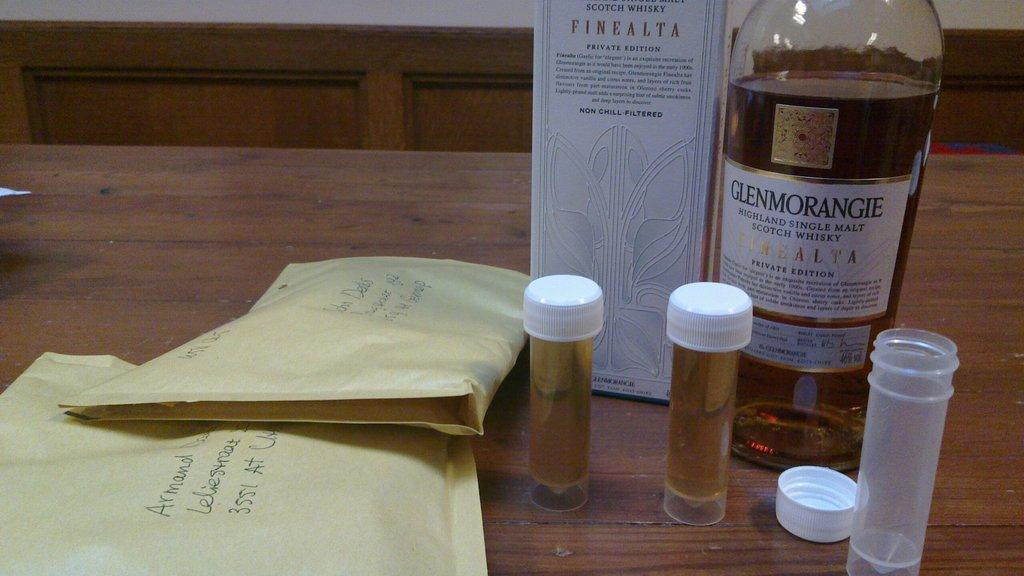What type of objects are covered in the image? There are covers in the image. What other object can be seen on the table? There is a bottle in the image. Are there any additional items on the table? Yes, there are tubes in the image. Where are these objects located? All of these objects are placed on a table. Is there a parcel being delivered in the image? There is no parcel or delivery depicted in the image. 